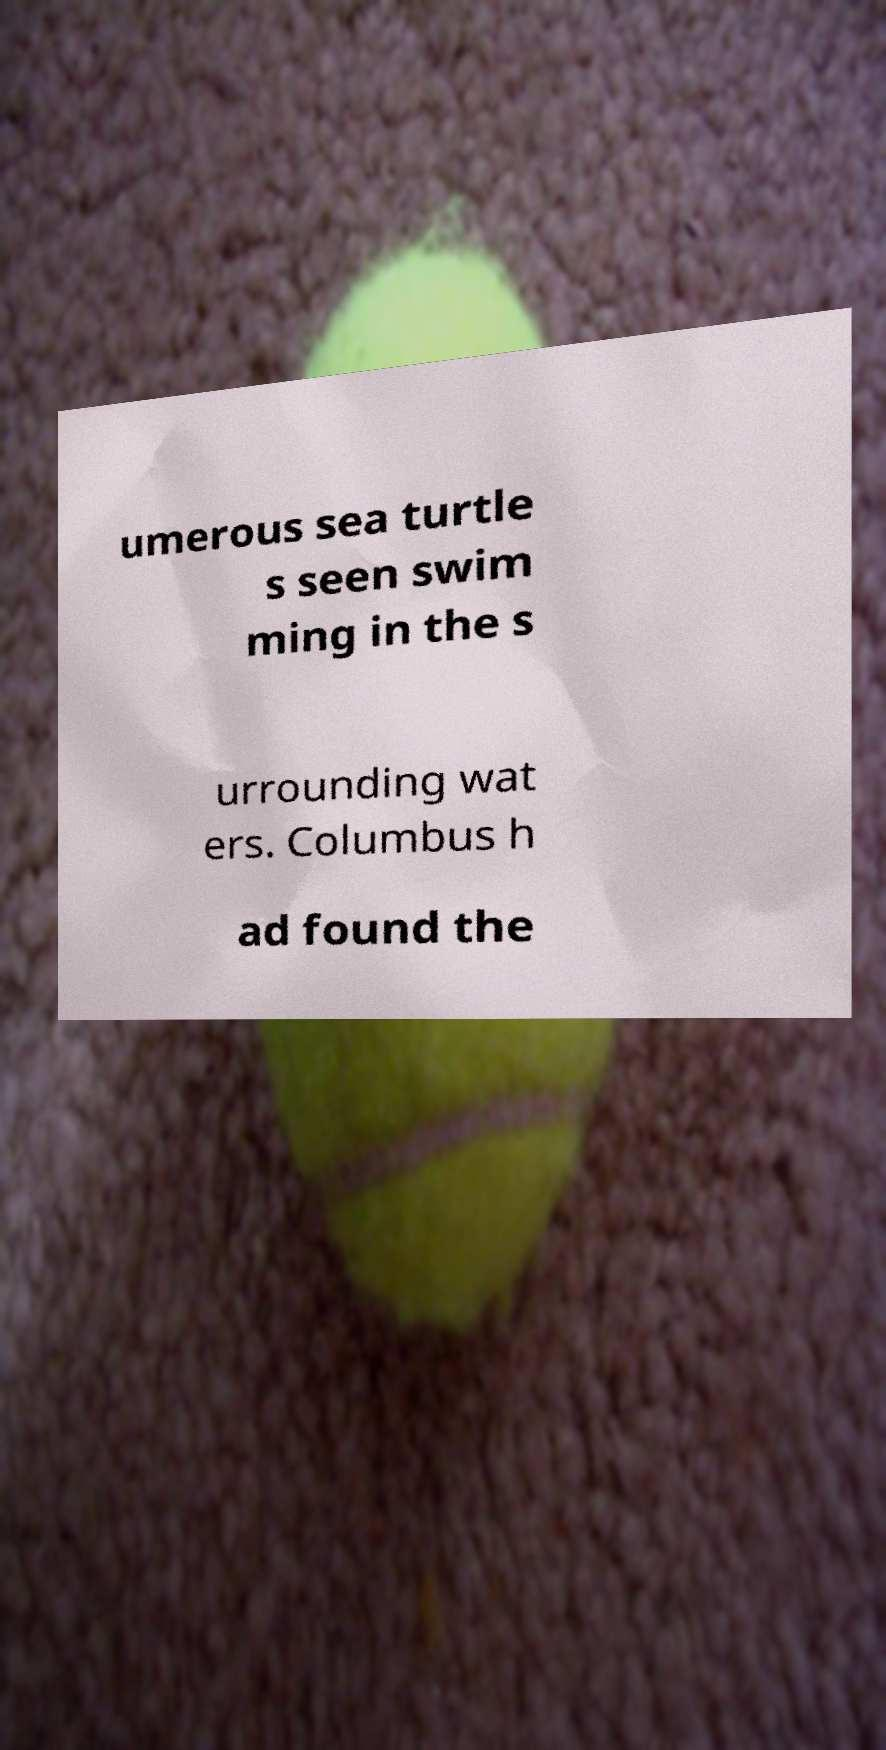Could you assist in decoding the text presented in this image and type it out clearly? umerous sea turtle s seen swim ming in the s urrounding wat ers. Columbus h ad found the 